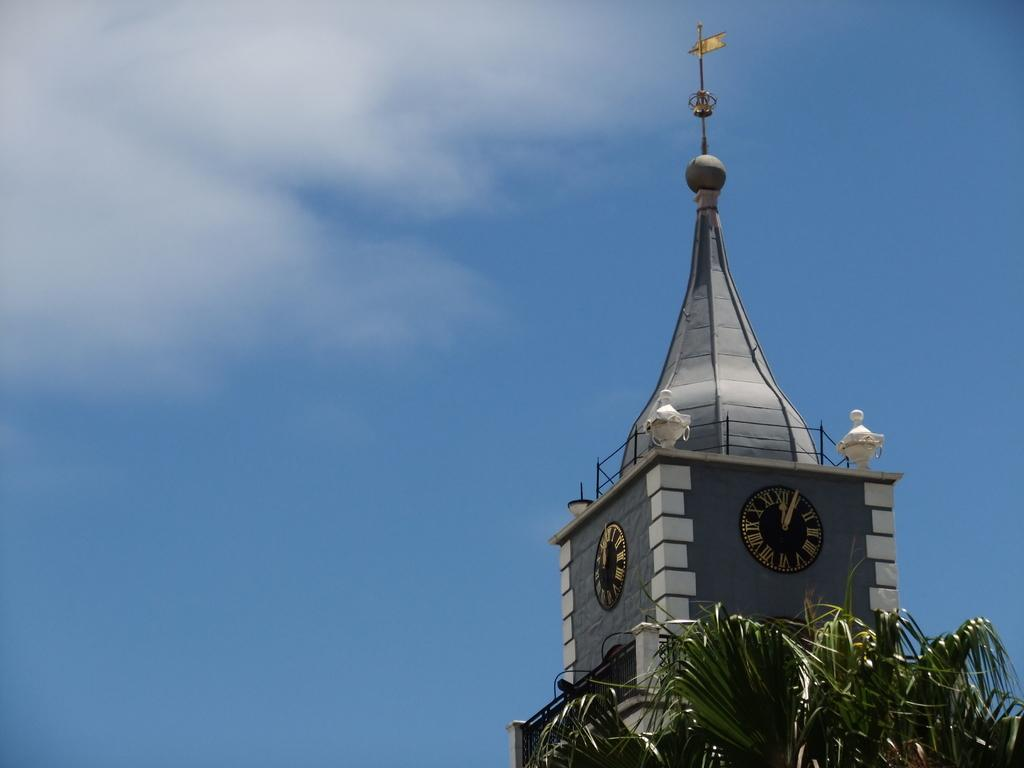What type of natural element is present on the right side of the image? There is a tree on the right side of the image. What type of man-made structure is also present on the right side of the image? There is a building on the right side of the image. How many clocks are on the building in the image? The building has 2 clocks. What is visible at the top of the image? The sky is visible at the top of the image. How many brothers are depicted in the image? There are no people, let alone brothers, present in the image. What type of tool is being used to fix the tree in the image? There is no tool or any indication of fixing in the image; it simply shows a tree and a building. 